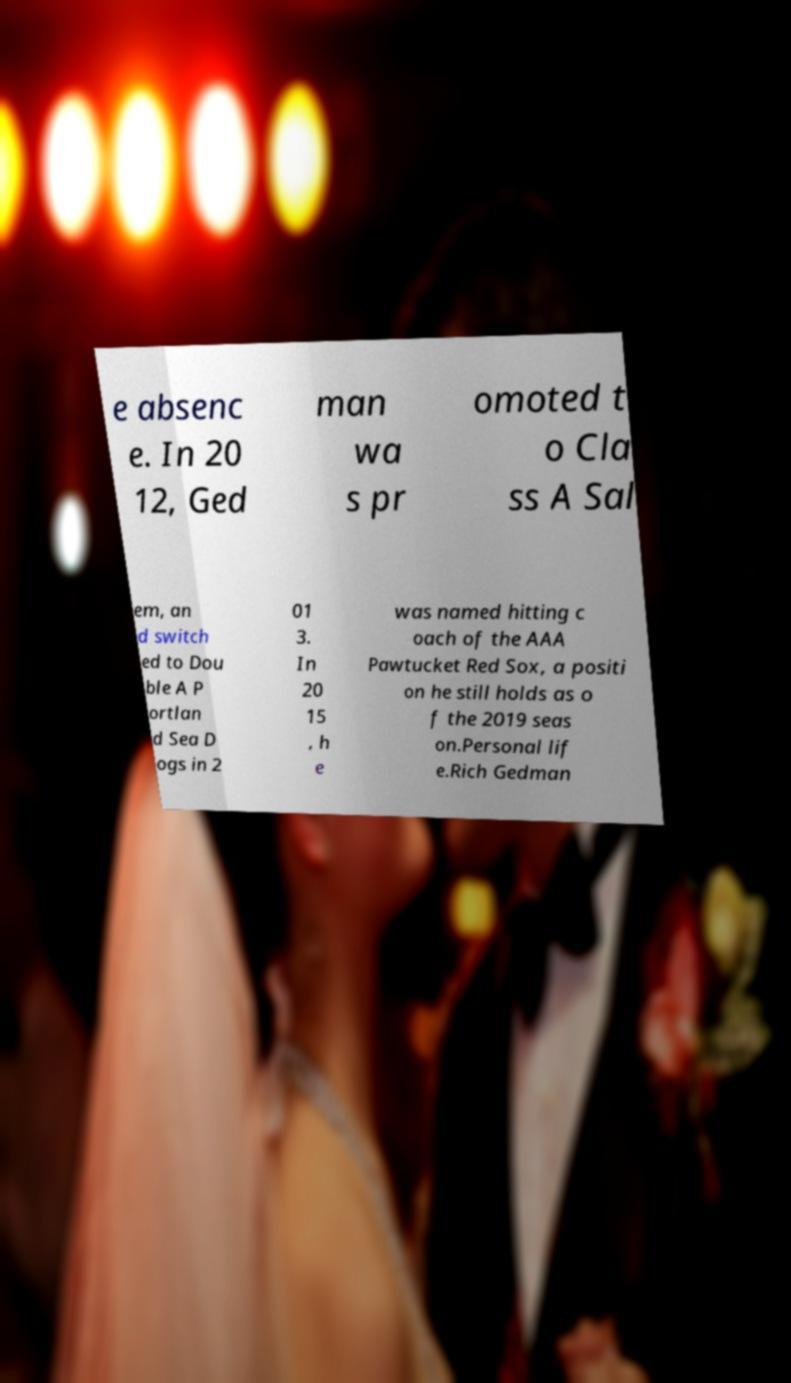Could you extract and type out the text from this image? e absenc e. In 20 12, Ged man wa s pr omoted t o Cla ss A Sal em, an d switch ed to Dou ble A P ortlan d Sea D ogs in 2 01 3. In 20 15 , h e was named hitting c oach of the AAA Pawtucket Red Sox, a positi on he still holds as o f the 2019 seas on.Personal lif e.Rich Gedman 